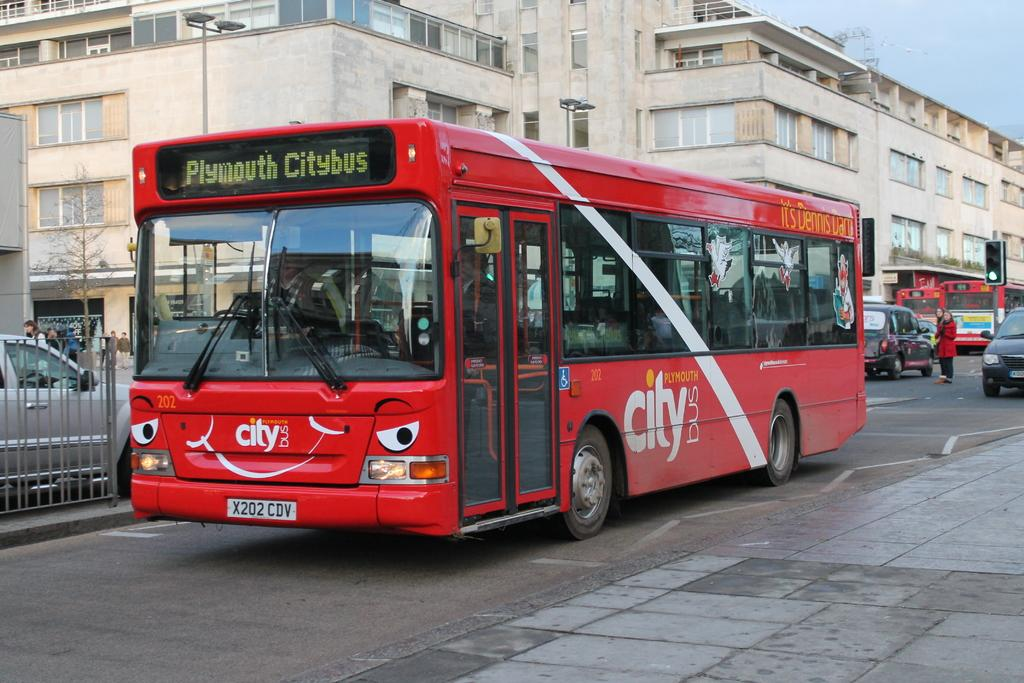<image>
Create a compact narrative representing the image presented. The Plymouth City bus is red and is on the street. 